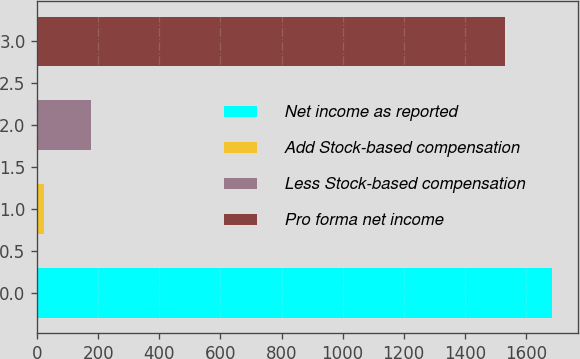<chart> <loc_0><loc_0><loc_500><loc_500><bar_chart><fcel>Net income as reported<fcel>Add Stock-based compensation<fcel>Less Stock-based compensation<fcel>Pro forma net income<nl><fcel>1686.66<fcel>20.7<fcel>175.46<fcel>1531.9<nl></chart> 